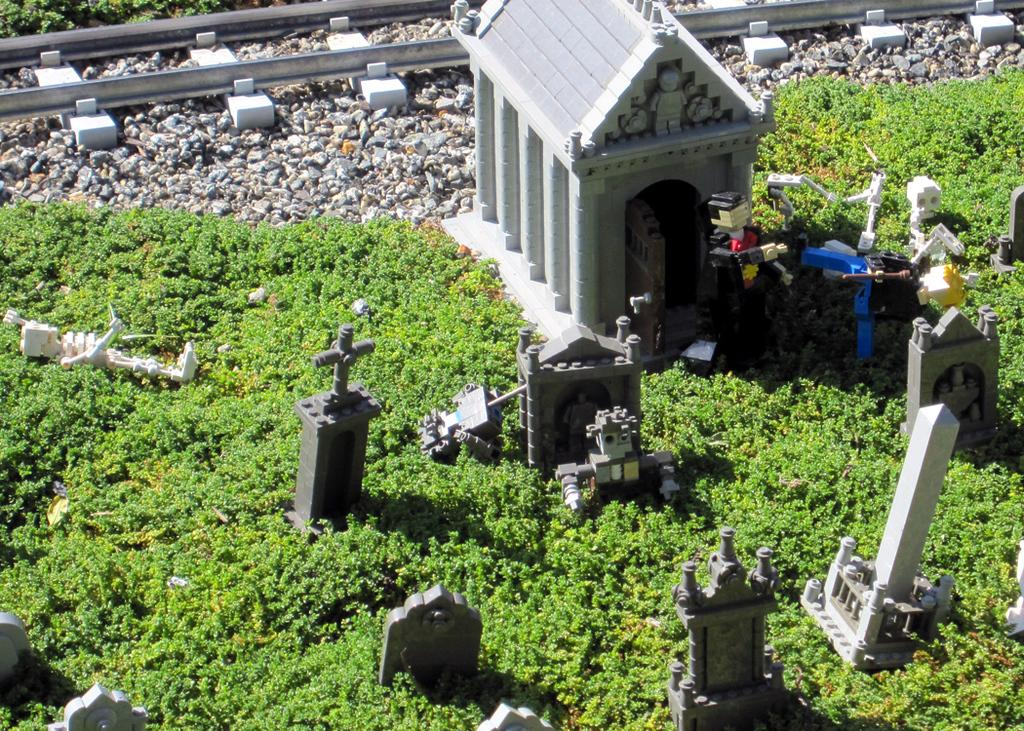What can be seen in the foreground of the image? In the foreground of the image, there are headstones, plants, a skeleton, a man, a shelter, stones, and a track. What type of plants are present in the foreground of the image? The plants in the foreground of the image are not specified, but they are present alongside the other elements mentioned. What is the man in the foreground of the image doing? The man's actions are not specified in the image, but he is present in the foreground alongside the other elements. What is the purpose of the shelter in the foreground of the image? The purpose of the shelter in the foreground of the image is not specified, but it is present alongside the other elements. How many geese are resting on the bed in the image? There are no geese or beds present in the image; it features headstones, plants, a skeleton, a man, a shelter, stones, and a track in the foreground. What type of drum is being played by the man in the image? There is no drum present in the image; the man is not depicted playing any musical instrument. 